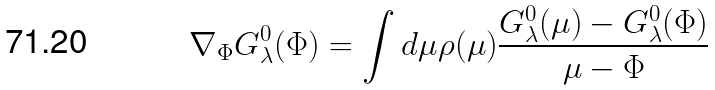Convert formula to latex. <formula><loc_0><loc_0><loc_500><loc_500>\nabla _ { \Phi } G ^ { 0 } _ { \lambda } ( \Phi ) = \int d \mu \rho ( \mu ) \frac { G ^ { 0 } _ { \lambda } ( \mu ) - G ^ { 0 } _ { \lambda } ( \Phi ) } { \mu - \Phi }</formula> 